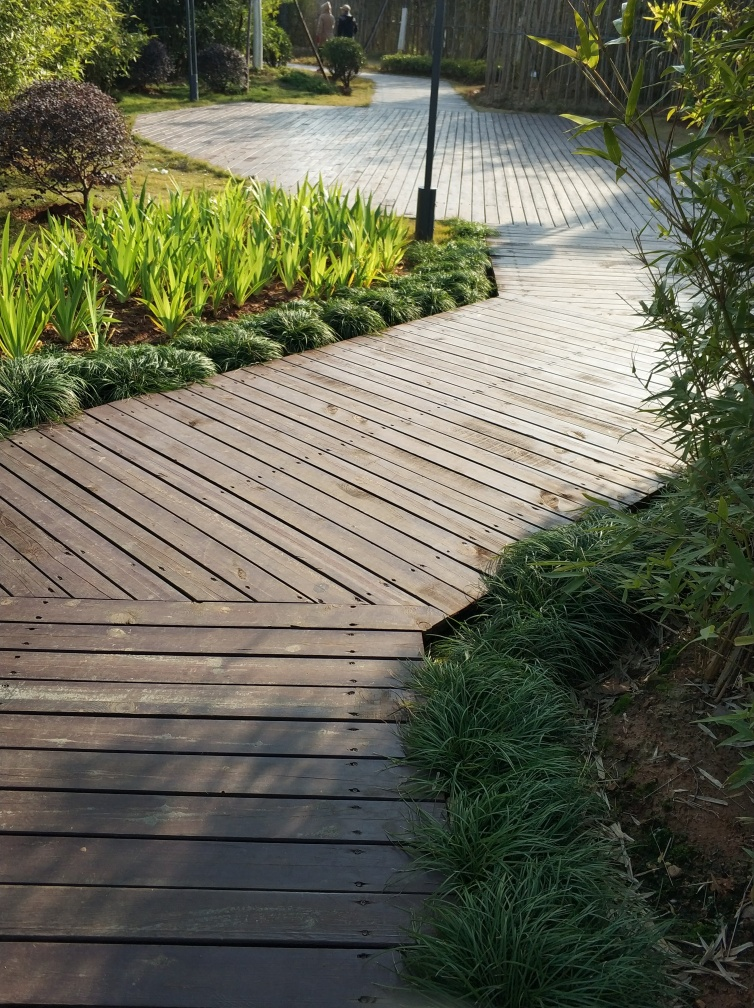Is this a suitable place for people with accessibility needs? Based on the image, the wooden pathway looks flat and even, which might make it accessible for wheelchairs or those with mobility aids. However, the accessibility would ultimately depend on the presence of ramps, the width of the path, and the absence of obstacles not visible in the image. 